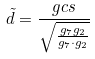Convert formula to latex. <formula><loc_0><loc_0><loc_500><loc_500>\tilde { d } = \frac { g c s } { \sqrt { \frac { g _ { 7 } g _ { 2 } } { g _ { 7 } \cdot g _ { 2 } } } }</formula> 